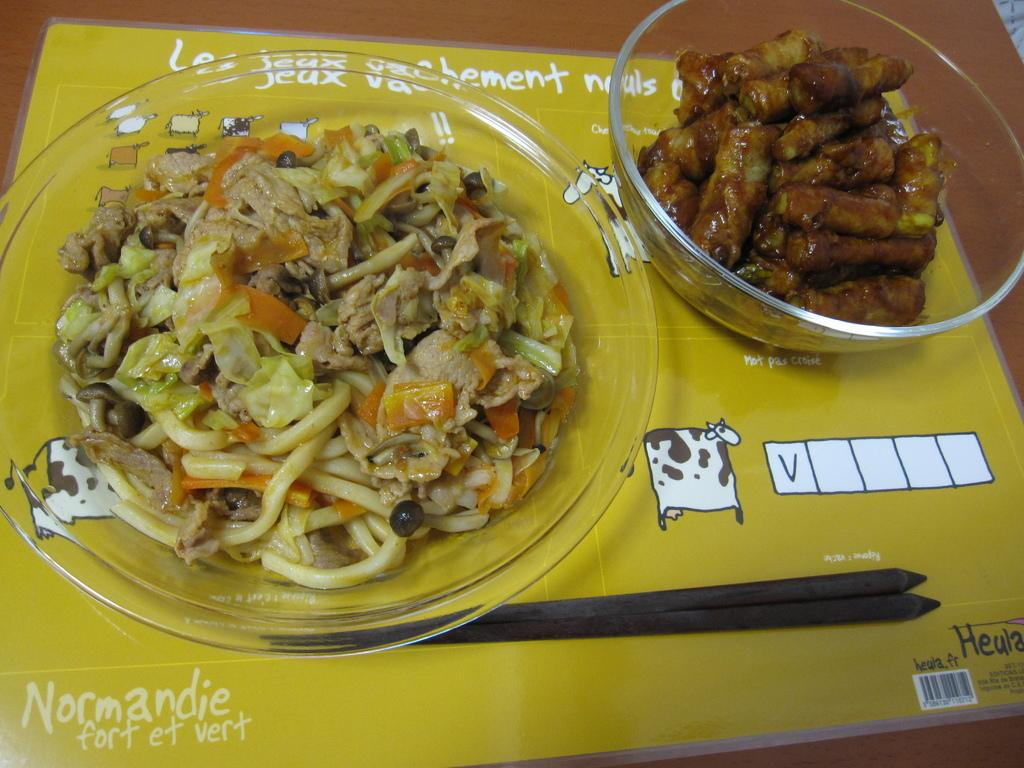What is inside the glass bowls in the image? There are food items in the glass bowls. What else can be seen in the image besides the glass bowls? There is a card and chopsticks on a wooden board in the image. Can you see a bee buzzing around the food items in the image? No, there is no bee present in the image. What mark is visible on the card in the image? There is no mark mentioned on the card in the provided facts, so we cannot determine if there is a mark on the card. 